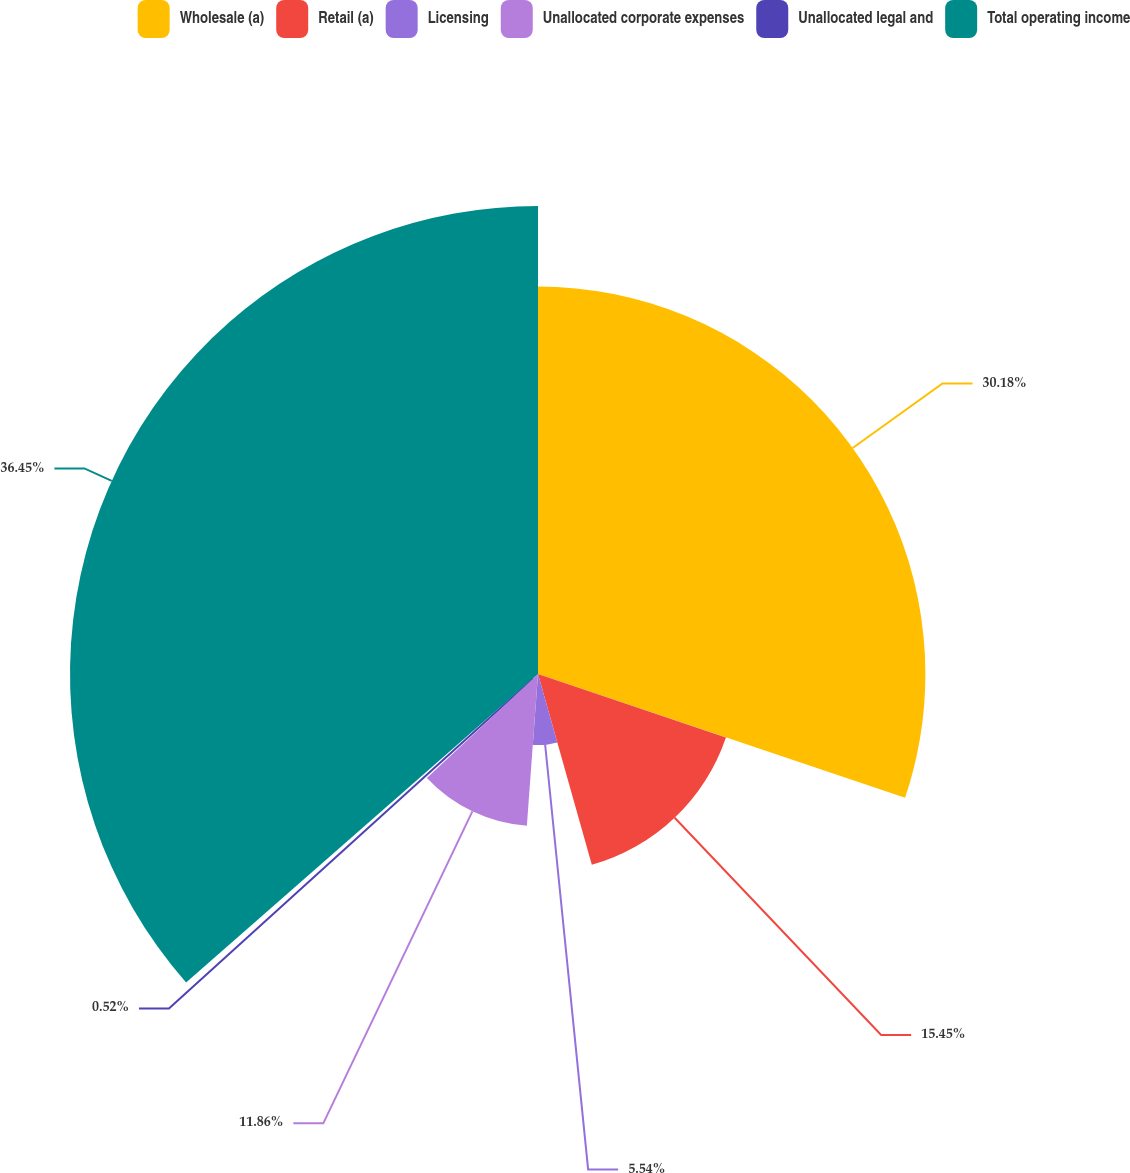<chart> <loc_0><loc_0><loc_500><loc_500><pie_chart><fcel>Wholesale (a)<fcel>Retail (a)<fcel>Licensing<fcel>Unallocated corporate expenses<fcel>Unallocated legal and<fcel>Total operating income<nl><fcel>30.18%<fcel>15.45%<fcel>5.54%<fcel>11.86%<fcel>0.52%<fcel>36.46%<nl></chart> 